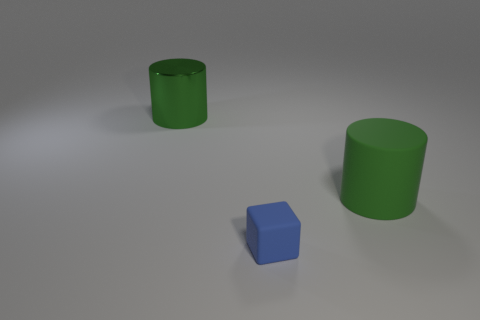Is there anything else that has the same size as the blue block?
Give a very brief answer. No. Is the cylinder that is to the right of the tiny blue thing made of the same material as the blue cube?
Ensure brevity in your answer.  Yes. What is the material of the small blue object?
Offer a terse response. Rubber. There is a green thing left of the blue block; how big is it?
Offer a very short reply. Large. Is there any other thing that is the same color as the tiny matte thing?
Make the answer very short. No. There is a cylinder behind the green cylinder to the right of the shiny cylinder; are there any blue things in front of it?
Your response must be concise. Yes. There is a large object that is right of the big metal object; is its color the same as the big metallic cylinder?
Your answer should be compact. Yes. How many spheres are big green metal objects or small cyan things?
Provide a short and direct response. 0. There is a rubber thing that is in front of the cylinder that is on the right side of the green shiny cylinder; what is its shape?
Your response must be concise. Cube. There is a cylinder to the right of the small blue thing in front of the green cylinder on the left side of the big green rubber thing; how big is it?
Offer a very short reply. Large. 